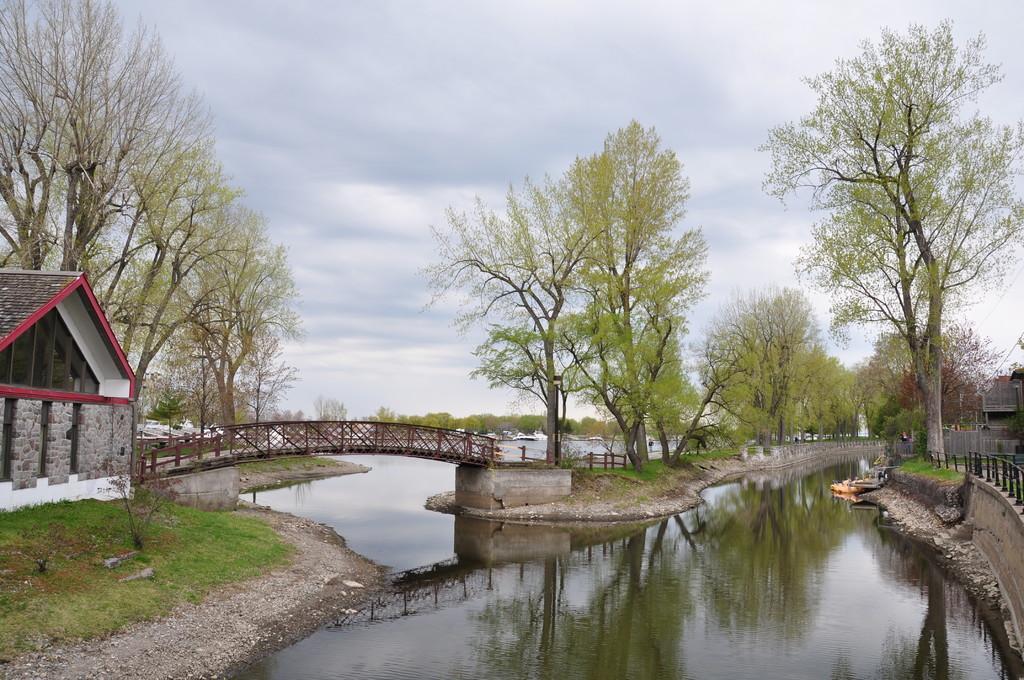Describe this image in one or two sentences. In this image we can see a bridge. Beside the bridge we can see the grass and trees. On the right side, we can see a wall, fencing, trees and a building. On the left side, we can see a house, grass and trees. At the bottom we can see the water. On the water we have the reflections of trees, bridge and the sky. In the background, we can see a group of trees and white objects looks like boats. At the top we can see the sky. 